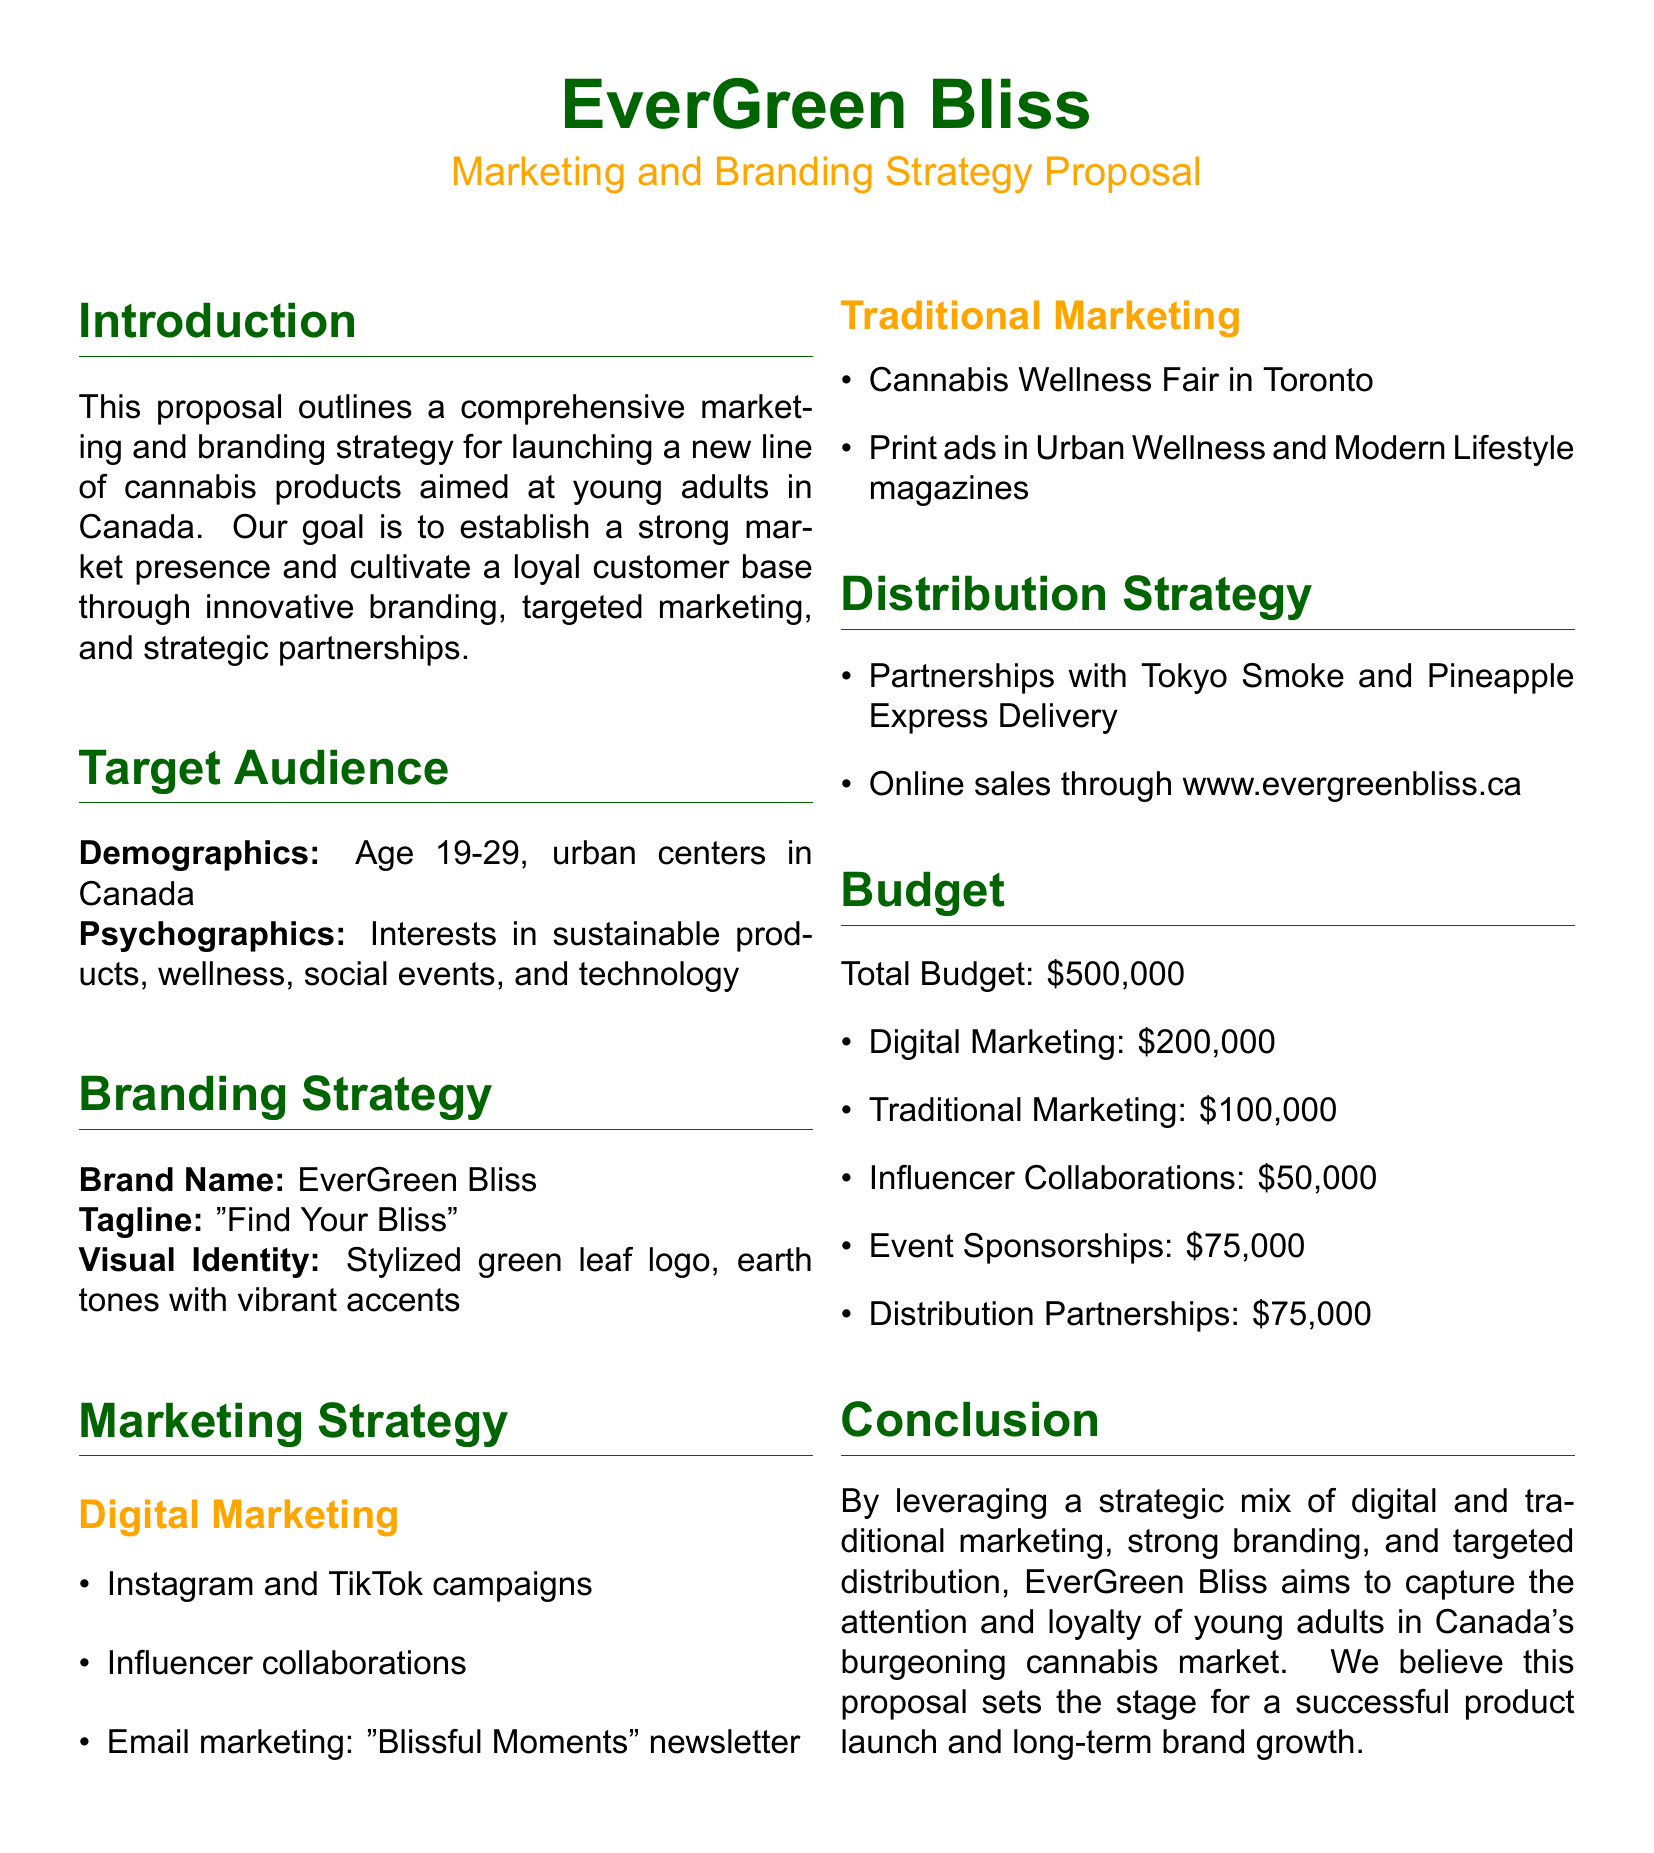what is the brand name of the product line? The brand name is specified in the branding strategy section of the document.
Answer: EverGreen Bliss what is the target age range for the audience? The age range is listed under the target audience section of the document.
Answer: 19-29 how much is allocated for digital marketing? The budget section specifies the breakdown of the total budget.
Answer: $200,000 what is the tagline for the product line? The tagline is detailed in the branding strategy section.
Answer: "Find Your Bliss" which two companies are mentioned for distribution partnerships? The partnerships for distribution are explicitly listed in the distribution strategy section.
Answer: Tokyo Smoke and Pineapple Express Delivery what type of marketing does the proposal emphasize for reaching young adults? This aspect is highlighted in the marketing strategy section, detailing the approach to engage the target audience.
Answer: Digital marketing how much is the total budget for the marketing proposal? The total budget is given in the budget section of the document.
Answer: $500,000 what is the focus of the cannabis wellness fair mentioned? The fair is referenced under the traditional marketing section, indicating its purpose.
Answer: Wellness how will the brand visually identify itself? The visual identity is described in the branding strategy section of the document.
Answer: Stylized green leaf logo what is the purpose of the "Blissful Moments" newsletter? The newsletter's purpose is outlined in the digital marketing subsection of the marketing strategy.
Answer: Email marketing 